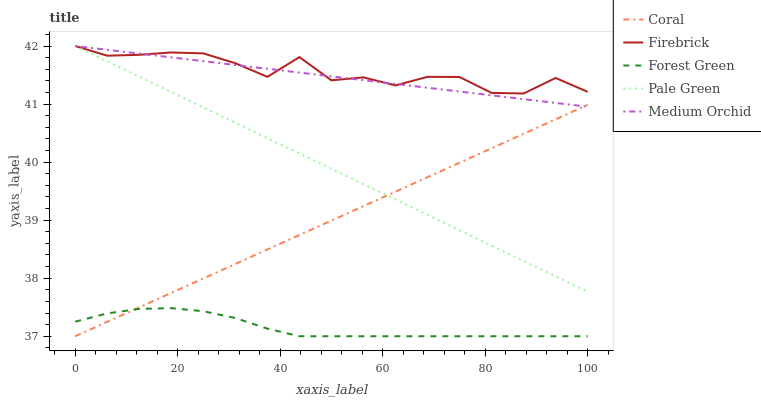Does Coral have the minimum area under the curve?
Answer yes or no. No. Does Coral have the maximum area under the curve?
Answer yes or no. No. Is Coral the smoothest?
Answer yes or no. No. Is Coral the roughest?
Answer yes or no. No. Does Pale Green have the lowest value?
Answer yes or no. No. Does Coral have the highest value?
Answer yes or no. No. Is Coral less than Firebrick?
Answer yes or no. Yes. Is Firebrick greater than Coral?
Answer yes or no. Yes. Does Coral intersect Firebrick?
Answer yes or no. No. 